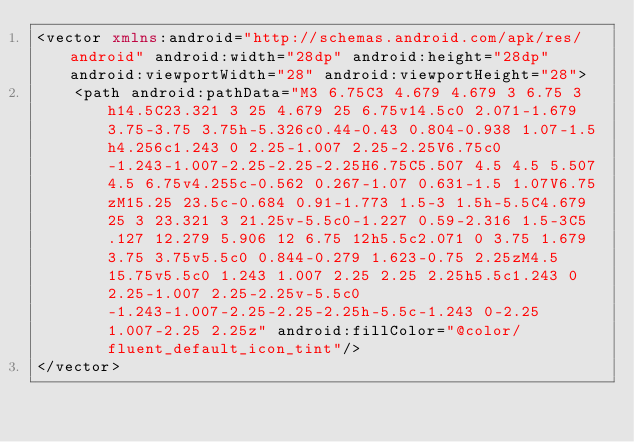Convert code to text. <code><loc_0><loc_0><loc_500><loc_500><_XML_><vector xmlns:android="http://schemas.android.com/apk/res/android" android:width="28dp" android:height="28dp" android:viewportWidth="28" android:viewportHeight="28">
    <path android:pathData="M3 6.75C3 4.679 4.679 3 6.75 3h14.5C23.321 3 25 4.679 25 6.75v14.5c0 2.071-1.679 3.75-3.75 3.75h-5.326c0.44-0.43 0.804-0.938 1.07-1.5h4.256c1.243 0 2.25-1.007 2.25-2.25V6.75c0-1.243-1.007-2.25-2.25-2.25H6.75C5.507 4.5 4.5 5.507 4.5 6.75v4.255c-0.562 0.267-1.07 0.631-1.5 1.07V6.75zM15.25 23.5c-0.684 0.91-1.773 1.5-3 1.5h-5.5C4.679 25 3 23.321 3 21.25v-5.5c0-1.227 0.59-2.316 1.5-3C5.127 12.279 5.906 12 6.75 12h5.5c2.071 0 3.75 1.679 3.75 3.75v5.5c0 0.844-0.279 1.623-0.75 2.25zM4.5 15.75v5.5c0 1.243 1.007 2.25 2.25 2.25h5.5c1.243 0 2.25-1.007 2.25-2.25v-5.5c0-1.243-1.007-2.25-2.25-2.25h-5.5c-1.243 0-2.25 1.007-2.25 2.25z" android:fillColor="@color/fluent_default_icon_tint"/>
</vector>
</code> 